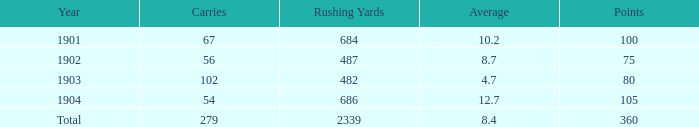7, and under 487 rushing yards? None. 